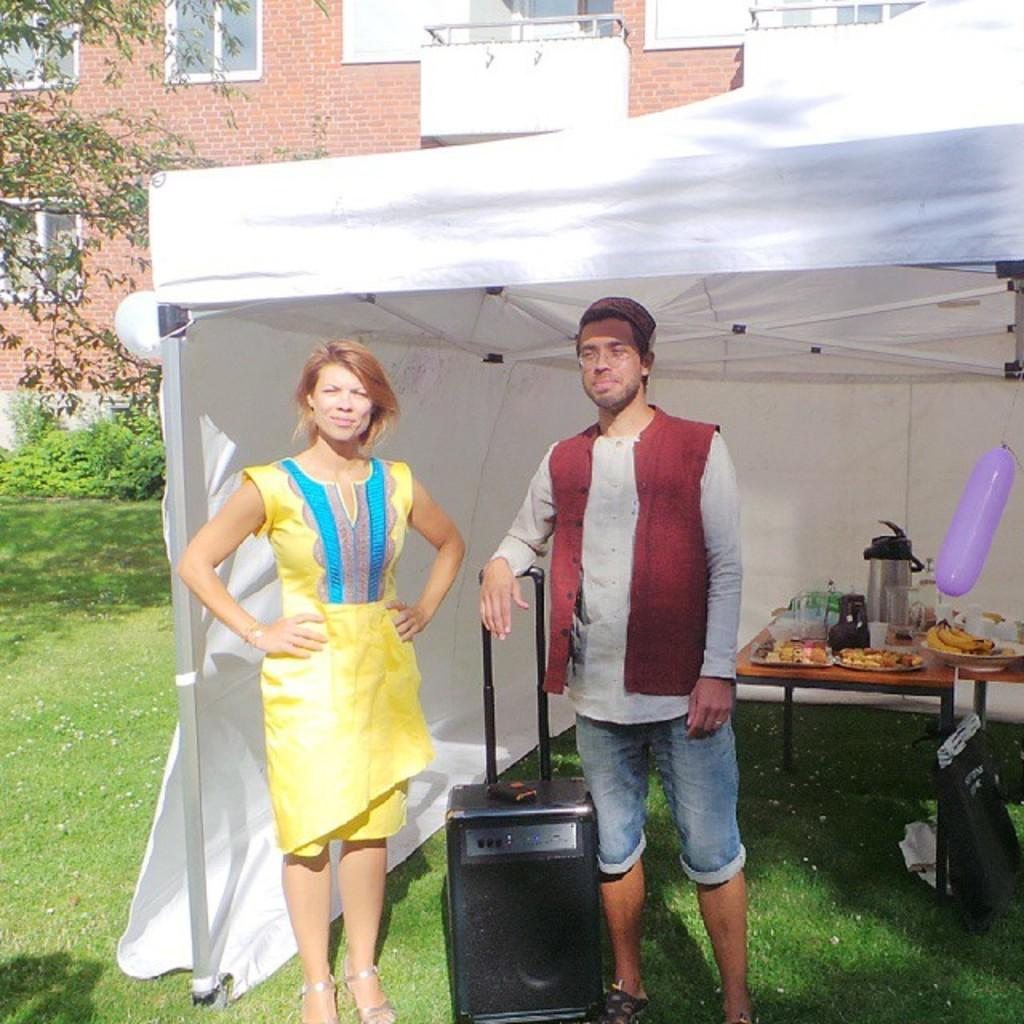Who is present in the image? There is a couple in the image. Where are the couple standing? The couple is standing under a tent. What can be seen between the couple? There is a portable music system in between the couple. What is present on the table in the image? There are eatables on the table. What grade did the couple receive for their performance in the image? There is no indication of a performance or grade in the image; it simply shows a couple standing under a tent with a portable music system and a table with eatables. 